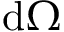<formula> <loc_0><loc_0><loc_500><loc_500>d \Omega</formula> 